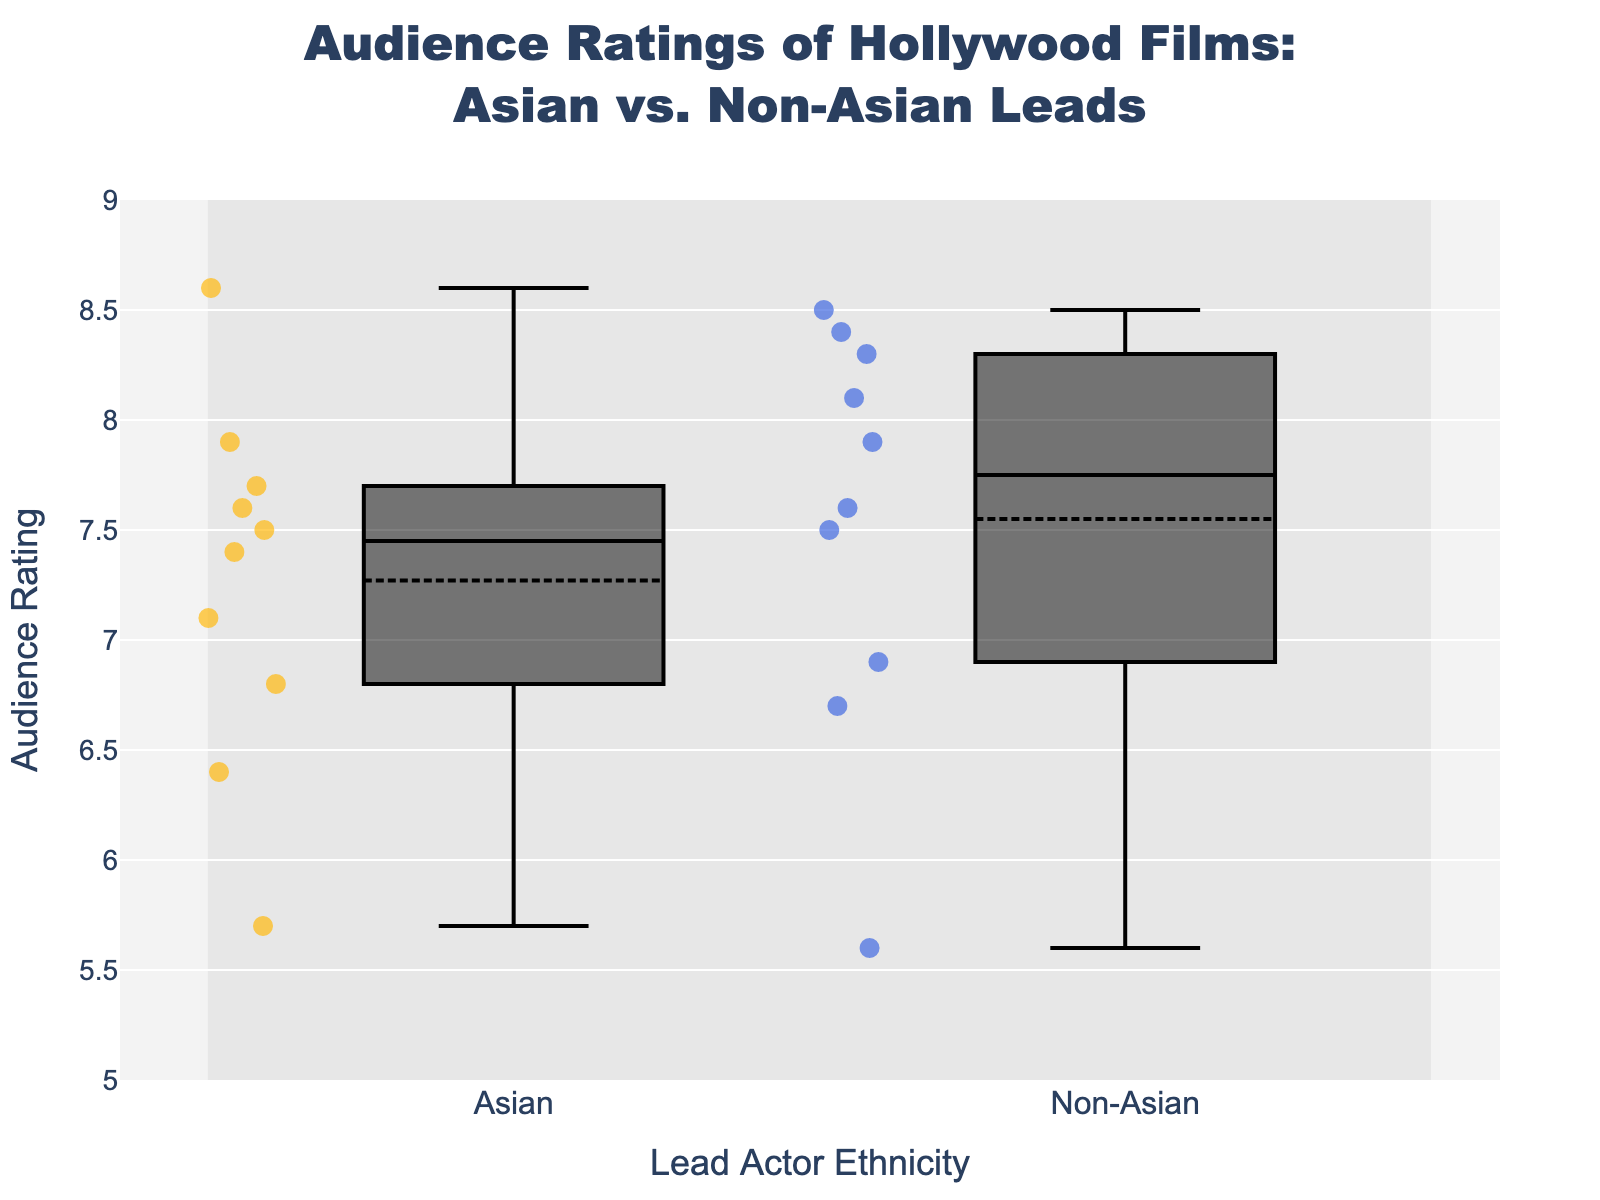what is the median rating for both Asian and Non-Asian lead films? For Asian leads, the median is the middle value when all ratings are listed in numerical order. For Non-Asian leads, similarly, the median is the middle value after arranging the ratings. For Non-Asian leads: [5.6, 6.7, 6.9, 7.5, 7.6, 7.9, 8.1, 8.3, 8.4, 8.5], the median is 7.75 (average of 7.6 and 7.9). For Asian leads: [5.7, 6.4, 6.8, 7.1, 7.4, 7.5, 7.6, 7.7, 7.9, 8.6], the median is 7.55 (average of 7.5 and 7.6).
Answer: 7.55, 7.75 Are there more ratings above 8.0 in Asian lead films or Non-Asian lead films? To answer this, count the number of ratings above 8.0 for each group from the scatter points. For Asian leads, only "Parasite" has a rating above 8.0. For Non-Asian leads, "Avengers: Endgame," "Joker," "Ford v Ferrari," and "1917" are above 8.0. Thus, Non-Asian lead films have more ratings above 8.0.
Answer: Non-Asian leads What is the audience rating range (difference between maximum and minimum ratings) for films with Asian leads? Identify the highest and lowest ratings from the scatter points for Asian leads: highest—'Parasite' (8.6), lowest—'Mulan (2020)' (5.7). Subtract the lowest from the highest: 8.6 - 5.7.
Answer: 2.9 Which film has the lowest rating overall, and what is it? Locate the lowest single scatter point on the y-axis across both groups. 'Dolittle' has the lowest rating among all data points, at 5.6.
Answer: Dolittle (5.6) Which group of films has a higher interquartile range (IQR)? The IQR is the difference between the 75th percentile (Q3) and the 25th percentile (Q1). In box plots, Q1 and Q3 are represented by the upper and lower edges of the box. By comparing the height of the boxes for Asian and Non-Asian leads, we determine the width, or length, of each IQR. The exact numbers require calculating these values from the data above. Asian leads have Q1 ~ 6.8, Q3 ~ 7.7 (IQR ~0.9). Non-Asian leads have Q1 ~ 6.925, Q3 ~8.275 (IQR ~1.35). Thus, Non-Asian leads have a higher IQR.
Answer: Non-Asian leads Is the median rating for Non-Asian leads higher than that for Asian leads? Compare the median values from the box plots. The median for Non-Asian leads is higher (7.75) compared to that for Asian leads (7.55).
Answer: Yes What is the spread (variance) of ratings like between the two groups? Assess the scatter points in both groups and evaluate the dots' distribution around the median. For Asian leads, ratings are more closely packed (less variance). For Non-Asian leads, ratings are spread out, suggesting more variance.
Answer: Non-Asian leads have higher variance 